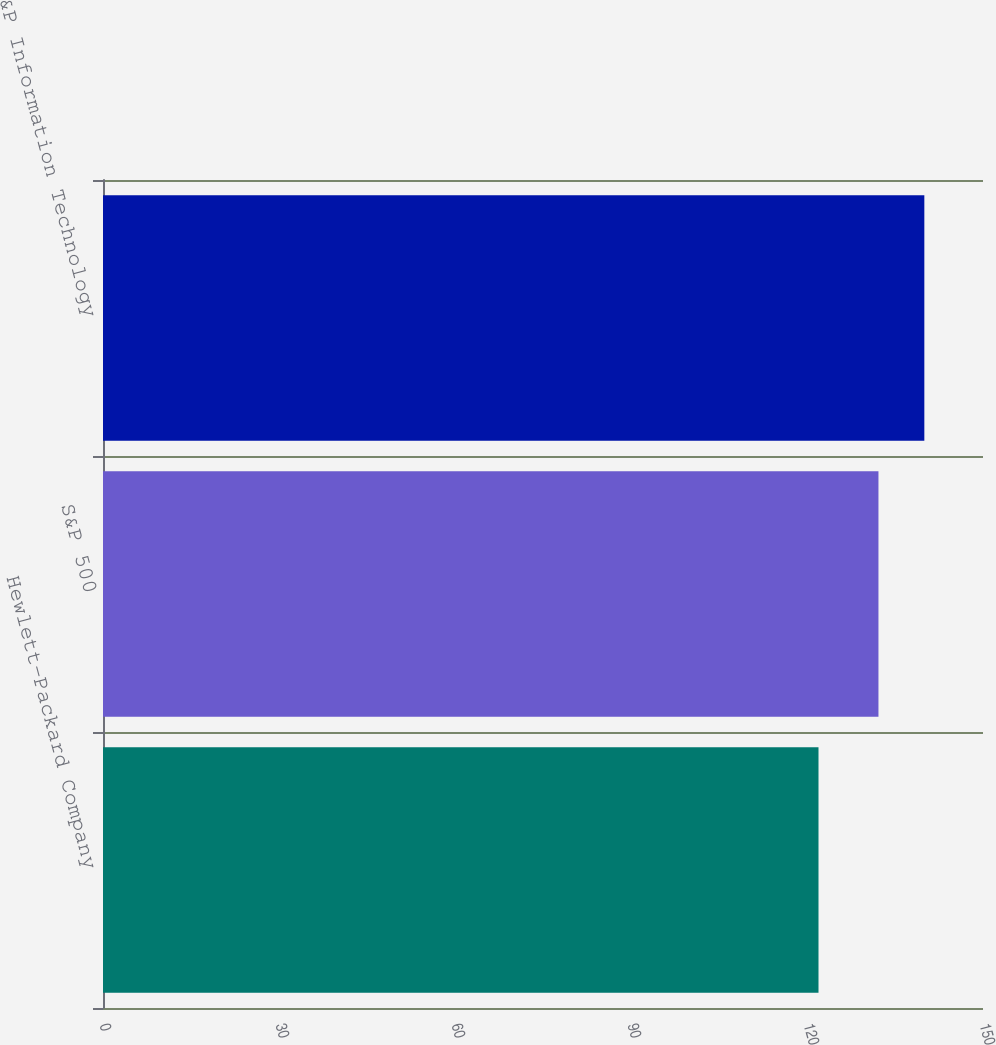Convert chart to OTSL. <chart><loc_0><loc_0><loc_500><loc_500><bar_chart><fcel>Hewlett-Packard Company<fcel>S&P 500<fcel>S&P Information Technology<nl><fcel>121.96<fcel>132.18<fcel>140<nl></chart> 